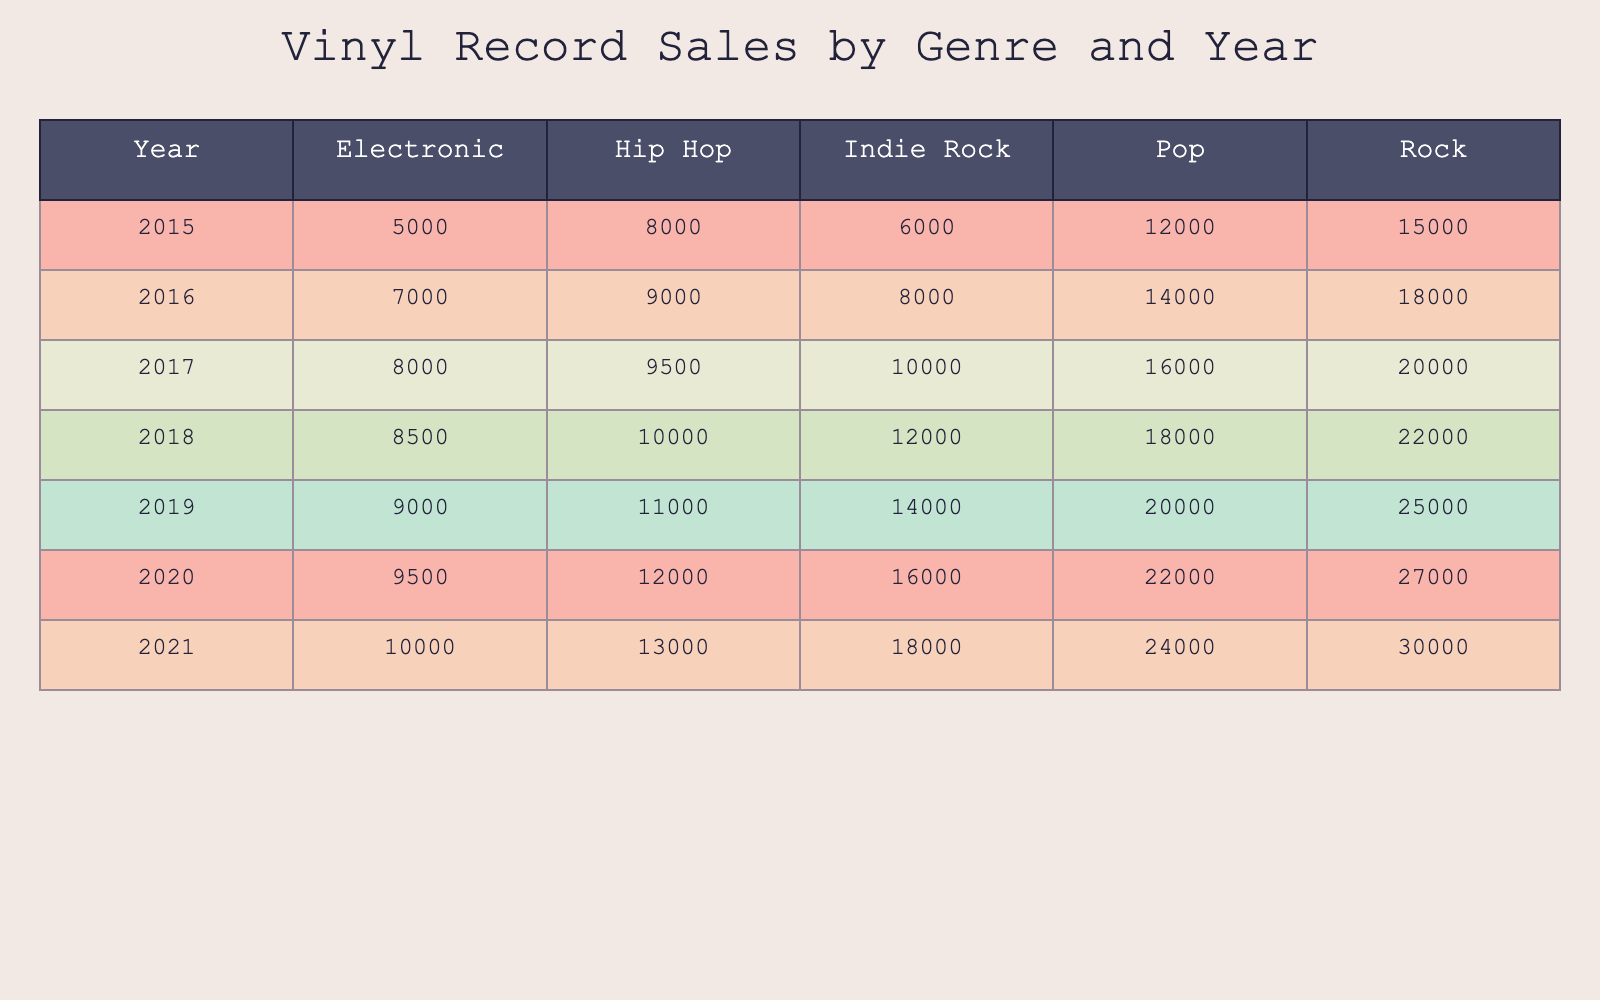What was the total sales for Indie Rock in 2019? Looking at the table for the year 2019 under the Indie Rock genre, the sales figure is 14,000. Therefore, the total sales for Indie Rock in 2019 is simply 14,000.
Answer: 14,000 In which year did Rock sales first exceed 25,000? By examining the table, the sales for Rock were as follows: 22,000 in 2018 and 25,000 in 2019. Therefore, the first year that Rock sales exceeded 25,000 is 2019.
Answer: 2019 What is the average sales of Electronic genre across all years? To find the average sales of Electronic genre, we first sum up the sales across all years: 5,000 (2015), 7,000 (2016), 8,000 (2017), 8,500 (2018), 9,000 (2019), 9,500 (2020), and 10,000 (2021). The total is 57,000. There are 7 data points, thus the average is 57,000 divided by 7, resulting in approximately 8,143.
Answer: 8,143 Was there an increase in sales for Hip Hop from 2020 to 2021? In 2020, Hip Hop sales were 12,000, and in 2021, they increased to 13,000. Since 13,000 is greater than 12,000, there was indeed an increase in sales for Hip Hop from 2020 to 2021.
Answer: Yes Which genre had the highest sales in 2016 and what was the amount? Referring to the table for the year 2016, we see the sales figures: Rock sold 18,000, Pop sold 14,000, Hip Hop sold 9,000, Electronic sold 7,000, and Indie Rock sold 8,000. The highest sales figure is 18,000 for the Rock genre.
Answer: Rock, 18,000 How much more did Rock sell compared to Indie Rock in 2017? From the table, Rock sales in 2017 were 20,000 and Indie Rock sales were 10,000. To find how much more Rock sold compared to Indie Rock, we subtract 10,000 from 20,000, resulting in 10,000 more sales for Rock compared to Indie Rock.
Answer: 10,000 In which genre was there the greatest growth in sales from 2015 to 2021? Analyzing the table, we can see the sales figures for each genre in 2015 and 2021 to find growth: Rock increased from 15,000 to 30,000 (growth of 15,000), Pop from 12,000 to 24,000 (growth of 12,000), Hip Hop from 8,000 to 13,000 (growth of 5,000), Electronic from 5,000 to 10,000 (growth of 5,000), and Indie Rock from 6,000 to 18,000 (growth of 12,000). The greatest growth in sales was for Rock with an increase of 15,000.
Answer: Rock 